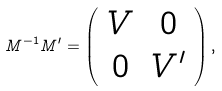Convert formula to latex. <formula><loc_0><loc_0><loc_500><loc_500>M ^ { - 1 } M ^ { \prime } = \left ( \begin{array} { c c } V & 0 \\ 0 & V ^ { \prime } \end{array} \right ) ,</formula> 